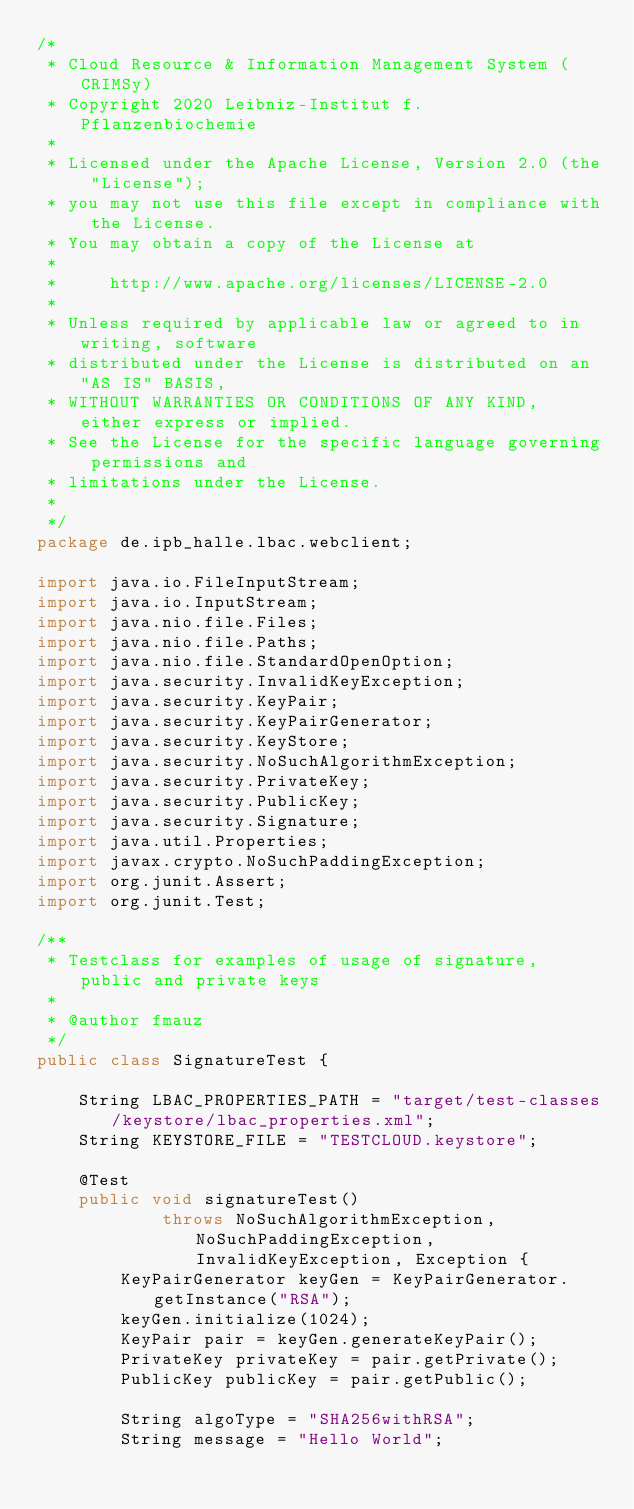Convert code to text. <code><loc_0><loc_0><loc_500><loc_500><_Java_>/*
 * Cloud Resource & Information Management System (CRIMSy)
 * Copyright 2020 Leibniz-Institut f. Pflanzenbiochemie
 *
 * Licensed under the Apache License, Version 2.0 (the "License");
 * you may not use this file except in compliance with the License.
 * You may obtain a copy of the License at
 *
 *     http://www.apache.org/licenses/LICENSE-2.0
 *
 * Unless required by applicable law or agreed to in writing, software
 * distributed under the License is distributed on an "AS IS" BASIS,
 * WITHOUT WARRANTIES OR CONDITIONS OF ANY KIND, either express or implied.
 * See the License for the specific language governing permissions and
 * limitations under the License.
 *
 */
package de.ipb_halle.lbac.webclient;

import java.io.FileInputStream;
import java.io.InputStream;
import java.nio.file.Files;
import java.nio.file.Paths;
import java.nio.file.StandardOpenOption;
import java.security.InvalidKeyException;
import java.security.KeyPair;
import java.security.KeyPairGenerator;
import java.security.KeyStore;
import java.security.NoSuchAlgorithmException;
import java.security.PrivateKey;
import java.security.PublicKey;
import java.security.Signature;
import java.util.Properties;
import javax.crypto.NoSuchPaddingException;
import org.junit.Assert;
import org.junit.Test;

/**
 * Testclass for examples of usage of signature, public and private keys
 *
 * @author fmauz
 */
public class SignatureTest {

    String LBAC_PROPERTIES_PATH = "target/test-classes/keystore/lbac_properties.xml";
    String KEYSTORE_FILE = "TESTCLOUD.keystore";

    @Test
    public void signatureTest()
            throws NoSuchAlgorithmException, NoSuchPaddingException, InvalidKeyException, Exception {
        KeyPairGenerator keyGen = KeyPairGenerator.getInstance("RSA");
        keyGen.initialize(1024);
        KeyPair pair = keyGen.generateKeyPair();
        PrivateKey privateKey = pair.getPrivate();
        PublicKey publicKey = pair.getPublic();

        String algoType = "SHA256withRSA";
        String message = "Hello World";
</code> 